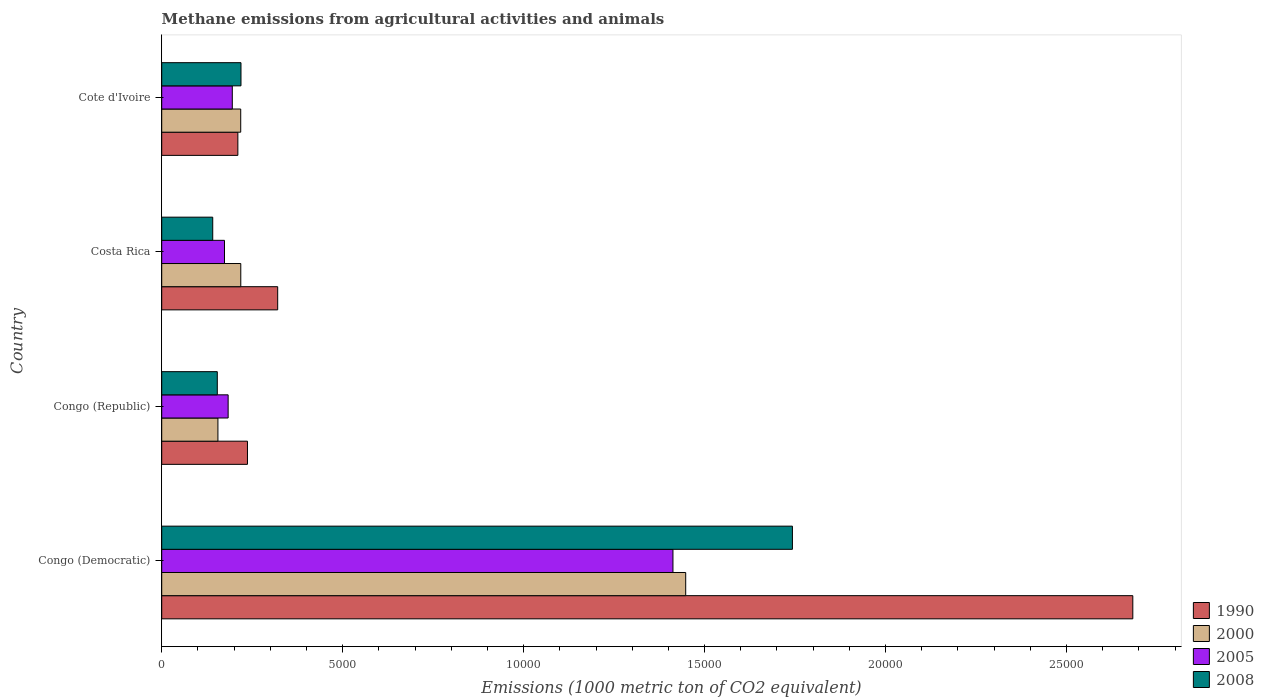Are the number of bars per tick equal to the number of legend labels?
Offer a terse response. Yes. Are the number of bars on each tick of the Y-axis equal?
Provide a succinct answer. Yes. How many bars are there on the 1st tick from the bottom?
Provide a short and direct response. 4. What is the label of the 1st group of bars from the top?
Your answer should be very brief. Cote d'Ivoire. In how many cases, is the number of bars for a given country not equal to the number of legend labels?
Offer a very short reply. 0. What is the amount of methane emitted in 2000 in Costa Rica?
Offer a very short reply. 2184.6. Across all countries, what is the maximum amount of methane emitted in 2005?
Make the answer very short. 1.41e+04. Across all countries, what is the minimum amount of methane emitted in 2005?
Ensure brevity in your answer.  1735. In which country was the amount of methane emitted in 2008 maximum?
Offer a very short reply. Congo (Democratic). In which country was the amount of methane emitted in 1990 minimum?
Your answer should be very brief. Cote d'Ivoire. What is the total amount of methane emitted in 2005 in the graph?
Ensure brevity in your answer.  1.96e+04. What is the difference between the amount of methane emitted in 2005 in Congo (Republic) and that in Costa Rica?
Offer a terse response. 100.4. What is the difference between the amount of methane emitted in 2008 in Congo (Democratic) and the amount of methane emitted in 1990 in Cote d'Ivoire?
Provide a succinct answer. 1.53e+04. What is the average amount of methane emitted in 2005 per country?
Give a very brief answer. 4911.57. What is the difference between the amount of methane emitted in 2005 and amount of methane emitted in 2008 in Cote d'Ivoire?
Your answer should be compact. -240.2. What is the ratio of the amount of methane emitted in 1990 in Congo (Republic) to that in Cote d'Ivoire?
Give a very brief answer. 1.13. Is the difference between the amount of methane emitted in 2005 in Congo (Democratic) and Cote d'Ivoire greater than the difference between the amount of methane emitted in 2008 in Congo (Democratic) and Cote d'Ivoire?
Keep it short and to the point. No. What is the difference between the highest and the second highest amount of methane emitted in 2005?
Offer a very short reply. 1.22e+04. What is the difference between the highest and the lowest amount of methane emitted in 1990?
Keep it short and to the point. 2.47e+04. In how many countries, is the amount of methane emitted in 2000 greater than the average amount of methane emitted in 2000 taken over all countries?
Your answer should be very brief. 1. Is it the case that in every country, the sum of the amount of methane emitted in 2008 and amount of methane emitted in 2000 is greater than the sum of amount of methane emitted in 2005 and amount of methane emitted in 1990?
Give a very brief answer. No. What does the 2nd bar from the top in Cote d'Ivoire represents?
Make the answer very short. 2005. Are all the bars in the graph horizontal?
Offer a terse response. Yes. How many countries are there in the graph?
Provide a succinct answer. 4. Does the graph contain any zero values?
Your response must be concise. No. How are the legend labels stacked?
Provide a succinct answer. Vertical. What is the title of the graph?
Make the answer very short. Methane emissions from agricultural activities and animals. What is the label or title of the X-axis?
Provide a succinct answer. Emissions (1000 metric ton of CO2 equivalent). What is the label or title of the Y-axis?
Provide a short and direct response. Country. What is the Emissions (1000 metric ton of CO2 equivalent) in 1990 in Congo (Democratic)?
Your response must be concise. 2.68e+04. What is the Emissions (1000 metric ton of CO2 equivalent) in 2000 in Congo (Democratic)?
Make the answer very short. 1.45e+04. What is the Emissions (1000 metric ton of CO2 equivalent) in 2005 in Congo (Democratic)?
Provide a short and direct response. 1.41e+04. What is the Emissions (1000 metric ton of CO2 equivalent) in 2008 in Congo (Democratic)?
Keep it short and to the point. 1.74e+04. What is the Emissions (1000 metric ton of CO2 equivalent) of 1990 in Congo (Republic)?
Make the answer very short. 2369.4. What is the Emissions (1000 metric ton of CO2 equivalent) of 2000 in Congo (Republic)?
Your answer should be compact. 1552.9. What is the Emissions (1000 metric ton of CO2 equivalent) in 2005 in Congo (Republic)?
Give a very brief answer. 1835.4. What is the Emissions (1000 metric ton of CO2 equivalent) in 2008 in Congo (Republic)?
Keep it short and to the point. 1535.9. What is the Emissions (1000 metric ton of CO2 equivalent) in 1990 in Costa Rica?
Provide a succinct answer. 3204.6. What is the Emissions (1000 metric ton of CO2 equivalent) of 2000 in Costa Rica?
Keep it short and to the point. 2184.6. What is the Emissions (1000 metric ton of CO2 equivalent) of 2005 in Costa Rica?
Provide a succinct answer. 1735. What is the Emissions (1000 metric ton of CO2 equivalent) in 2008 in Costa Rica?
Make the answer very short. 1409.6. What is the Emissions (1000 metric ton of CO2 equivalent) of 1990 in Cote d'Ivoire?
Your response must be concise. 2104. What is the Emissions (1000 metric ton of CO2 equivalent) in 2000 in Cote d'Ivoire?
Ensure brevity in your answer.  2183.1. What is the Emissions (1000 metric ton of CO2 equivalent) of 2005 in Cote d'Ivoire?
Provide a succinct answer. 1950.1. What is the Emissions (1000 metric ton of CO2 equivalent) of 2008 in Cote d'Ivoire?
Your response must be concise. 2190.3. Across all countries, what is the maximum Emissions (1000 metric ton of CO2 equivalent) of 1990?
Provide a short and direct response. 2.68e+04. Across all countries, what is the maximum Emissions (1000 metric ton of CO2 equivalent) of 2000?
Make the answer very short. 1.45e+04. Across all countries, what is the maximum Emissions (1000 metric ton of CO2 equivalent) in 2005?
Provide a short and direct response. 1.41e+04. Across all countries, what is the maximum Emissions (1000 metric ton of CO2 equivalent) in 2008?
Provide a short and direct response. 1.74e+04. Across all countries, what is the minimum Emissions (1000 metric ton of CO2 equivalent) of 1990?
Keep it short and to the point. 2104. Across all countries, what is the minimum Emissions (1000 metric ton of CO2 equivalent) of 2000?
Ensure brevity in your answer.  1552.9. Across all countries, what is the minimum Emissions (1000 metric ton of CO2 equivalent) of 2005?
Give a very brief answer. 1735. Across all countries, what is the minimum Emissions (1000 metric ton of CO2 equivalent) of 2008?
Provide a short and direct response. 1409.6. What is the total Emissions (1000 metric ton of CO2 equivalent) in 1990 in the graph?
Your response must be concise. 3.45e+04. What is the total Emissions (1000 metric ton of CO2 equivalent) in 2000 in the graph?
Your response must be concise. 2.04e+04. What is the total Emissions (1000 metric ton of CO2 equivalent) in 2005 in the graph?
Offer a very short reply. 1.96e+04. What is the total Emissions (1000 metric ton of CO2 equivalent) of 2008 in the graph?
Your answer should be very brief. 2.26e+04. What is the difference between the Emissions (1000 metric ton of CO2 equivalent) of 1990 in Congo (Democratic) and that in Congo (Republic)?
Give a very brief answer. 2.45e+04. What is the difference between the Emissions (1000 metric ton of CO2 equivalent) in 2000 in Congo (Democratic) and that in Congo (Republic)?
Ensure brevity in your answer.  1.29e+04. What is the difference between the Emissions (1000 metric ton of CO2 equivalent) of 2005 in Congo (Democratic) and that in Congo (Republic)?
Ensure brevity in your answer.  1.23e+04. What is the difference between the Emissions (1000 metric ton of CO2 equivalent) in 2008 in Congo (Democratic) and that in Congo (Republic)?
Offer a terse response. 1.59e+04. What is the difference between the Emissions (1000 metric ton of CO2 equivalent) of 1990 in Congo (Democratic) and that in Costa Rica?
Your answer should be very brief. 2.36e+04. What is the difference between the Emissions (1000 metric ton of CO2 equivalent) in 2000 in Congo (Democratic) and that in Costa Rica?
Offer a terse response. 1.23e+04. What is the difference between the Emissions (1000 metric ton of CO2 equivalent) of 2005 in Congo (Democratic) and that in Costa Rica?
Give a very brief answer. 1.24e+04. What is the difference between the Emissions (1000 metric ton of CO2 equivalent) in 2008 in Congo (Democratic) and that in Costa Rica?
Keep it short and to the point. 1.60e+04. What is the difference between the Emissions (1000 metric ton of CO2 equivalent) in 1990 in Congo (Democratic) and that in Cote d'Ivoire?
Provide a succinct answer. 2.47e+04. What is the difference between the Emissions (1000 metric ton of CO2 equivalent) in 2000 in Congo (Democratic) and that in Cote d'Ivoire?
Provide a succinct answer. 1.23e+04. What is the difference between the Emissions (1000 metric ton of CO2 equivalent) in 2005 in Congo (Democratic) and that in Cote d'Ivoire?
Your response must be concise. 1.22e+04. What is the difference between the Emissions (1000 metric ton of CO2 equivalent) of 2008 in Congo (Democratic) and that in Cote d'Ivoire?
Your answer should be compact. 1.52e+04. What is the difference between the Emissions (1000 metric ton of CO2 equivalent) in 1990 in Congo (Republic) and that in Costa Rica?
Your answer should be very brief. -835.2. What is the difference between the Emissions (1000 metric ton of CO2 equivalent) in 2000 in Congo (Republic) and that in Costa Rica?
Keep it short and to the point. -631.7. What is the difference between the Emissions (1000 metric ton of CO2 equivalent) of 2005 in Congo (Republic) and that in Costa Rica?
Make the answer very short. 100.4. What is the difference between the Emissions (1000 metric ton of CO2 equivalent) in 2008 in Congo (Republic) and that in Costa Rica?
Provide a short and direct response. 126.3. What is the difference between the Emissions (1000 metric ton of CO2 equivalent) in 1990 in Congo (Republic) and that in Cote d'Ivoire?
Make the answer very short. 265.4. What is the difference between the Emissions (1000 metric ton of CO2 equivalent) of 2000 in Congo (Republic) and that in Cote d'Ivoire?
Ensure brevity in your answer.  -630.2. What is the difference between the Emissions (1000 metric ton of CO2 equivalent) of 2005 in Congo (Republic) and that in Cote d'Ivoire?
Your response must be concise. -114.7. What is the difference between the Emissions (1000 metric ton of CO2 equivalent) in 2008 in Congo (Republic) and that in Cote d'Ivoire?
Your response must be concise. -654.4. What is the difference between the Emissions (1000 metric ton of CO2 equivalent) in 1990 in Costa Rica and that in Cote d'Ivoire?
Offer a terse response. 1100.6. What is the difference between the Emissions (1000 metric ton of CO2 equivalent) of 2000 in Costa Rica and that in Cote d'Ivoire?
Your answer should be compact. 1.5. What is the difference between the Emissions (1000 metric ton of CO2 equivalent) of 2005 in Costa Rica and that in Cote d'Ivoire?
Make the answer very short. -215.1. What is the difference between the Emissions (1000 metric ton of CO2 equivalent) in 2008 in Costa Rica and that in Cote d'Ivoire?
Make the answer very short. -780.7. What is the difference between the Emissions (1000 metric ton of CO2 equivalent) in 1990 in Congo (Democratic) and the Emissions (1000 metric ton of CO2 equivalent) in 2000 in Congo (Republic)?
Make the answer very short. 2.53e+04. What is the difference between the Emissions (1000 metric ton of CO2 equivalent) in 1990 in Congo (Democratic) and the Emissions (1000 metric ton of CO2 equivalent) in 2005 in Congo (Republic)?
Your answer should be very brief. 2.50e+04. What is the difference between the Emissions (1000 metric ton of CO2 equivalent) in 1990 in Congo (Democratic) and the Emissions (1000 metric ton of CO2 equivalent) in 2008 in Congo (Republic)?
Ensure brevity in your answer.  2.53e+04. What is the difference between the Emissions (1000 metric ton of CO2 equivalent) of 2000 in Congo (Democratic) and the Emissions (1000 metric ton of CO2 equivalent) of 2005 in Congo (Republic)?
Make the answer very short. 1.26e+04. What is the difference between the Emissions (1000 metric ton of CO2 equivalent) of 2000 in Congo (Democratic) and the Emissions (1000 metric ton of CO2 equivalent) of 2008 in Congo (Republic)?
Your response must be concise. 1.29e+04. What is the difference between the Emissions (1000 metric ton of CO2 equivalent) of 2005 in Congo (Democratic) and the Emissions (1000 metric ton of CO2 equivalent) of 2008 in Congo (Republic)?
Your response must be concise. 1.26e+04. What is the difference between the Emissions (1000 metric ton of CO2 equivalent) in 1990 in Congo (Democratic) and the Emissions (1000 metric ton of CO2 equivalent) in 2000 in Costa Rica?
Your response must be concise. 2.46e+04. What is the difference between the Emissions (1000 metric ton of CO2 equivalent) of 1990 in Congo (Democratic) and the Emissions (1000 metric ton of CO2 equivalent) of 2005 in Costa Rica?
Your answer should be compact. 2.51e+04. What is the difference between the Emissions (1000 metric ton of CO2 equivalent) in 1990 in Congo (Democratic) and the Emissions (1000 metric ton of CO2 equivalent) in 2008 in Costa Rica?
Your answer should be compact. 2.54e+04. What is the difference between the Emissions (1000 metric ton of CO2 equivalent) of 2000 in Congo (Democratic) and the Emissions (1000 metric ton of CO2 equivalent) of 2005 in Costa Rica?
Provide a succinct answer. 1.27e+04. What is the difference between the Emissions (1000 metric ton of CO2 equivalent) in 2000 in Congo (Democratic) and the Emissions (1000 metric ton of CO2 equivalent) in 2008 in Costa Rica?
Your answer should be very brief. 1.31e+04. What is the difference between the Emissions (1000 metric ton of CO2 equivalent) in 2005 in Congo (Democratic) and the Emissions (1000 metric ton of CO2 equivalent) in 2008 in Costa Rica?
Your response must be concise. 1.27e+04. What is the difference between the Emissions (1000 metric ton of CO2 equivalent) of 1990 in Congo (Democratic) and the Emissions (1000 metric ton of CO2 equivalent) of 2000 in Cote d'Ivoire?
Your answer should be very brief. 2.46e+04. What is the difference between the Emissions (1000 metric ton of CO2 equivalent) in 1990 in Congo (Democratic) and the Emissions (1000 metric ton of CO2 equivalent) in 2005 in Cote d'Ivoire?
Your answer should be compact. 2.49e+04. What is the difference between the Emissions (1000 metric ton of CO2 equivalent) of 1990 in Congo (Democratic) and the Emissions (1000 metric ton of CO2 equivalent) of 2008 in Cote d'Ivoire?
Provide a short and direct response. 2.46e+04. What is the difference between the Emissions (1000 metric ton of CO2 equivalent) in 2000 in Congo (Democratic) and the Emissions (1000 metric ton of CO2 equivalent) in 2005 in Cote d'Ivoire?
Offer a very short reply. 1.25e+04. What is the difference between the Emissions (1000 metric ton of CO2 equivalent) of 2000 in Congo (Democratic) and the Emissions (1000 metric ton of CO2 equivalent) of 2008 in Cote d'Ivoire?
Keep it short and to the point. 1.23e+04. What is the difference between the Emissions (1000 metric ton of CO2 equivalent) in 2005 in Congo (Democratic) and the Emissions (1000 metric ton of CO2 equivalent) in 2008 in Cote d'Ivoire?
Keep it short and to the point. 1.19e+04. What is the difference between the Emissions (1000 metric ton of CO2 equivalent) of 1990 in Congo (Republic) and the Emissions (1000 metric ton of CO2 equivalent) of 2000 in Costa Rica?
Your response must be concise. 184.8. What is the difference between the Emissions (1000 metric ton of CO2 equivalent) in 1990 in Congo (Republic) and the Emissions (1000 metric ton of CO2 equivalent) in 2005 in Costa Rica?
Provide a short and direct response. 634.4. What is the difference between the Emissions (1000 metric ton of CO2 equivalent) in 1990 in Congo (Republic) and the Emissions (1000 metric ton of CO2 equivalent) in 2008 in Costa Rica?
Provide a short and direct response. 959.8. What is the difference between the Emissions (1000 metric ton of CO2 equivalent) in 2000 in Congo (Republic) and the Emissions (1000 metric ton of CO2 equivalent) in 2005 in Costa Rica?
Your answer should be compact. -182.1. What is the difference between the Emissions (1000 metric ton of CO2 equivalent) of 2000 in Congo (Republic) and the Emissions (1000 metric ton of CO2 equivalent) of 2008 in Costa Rica?
Make the answer very short. 143.3. What is the difference between the Emissions (1000 metric ton of CO2 equivalent) of 2005 in Congo (Republic) and the Emissions (1000 metric ton of CO2 equivalent) of 2008 in Costa Rica?
Ensure brevity in your answer.  425.8. What is the difference between the Emissions (1000 metric ton of CO2 equivalent) in 1990 in Congo (Republic) and the Emissions (1000 metric ton of CO2 equivalent) in 2000 in Cote d'Ivoire?
Give a very brief answer. 186.3. What is the difference between the Emissions (1000 metric ton of CO2 equivalent) in 1990 in Congo (Republic) and the Emissions (1000 metric ton of CO2 equivalent) in 2005 in Cote d'Ivoire?
Your response must be concise. 419.3. What is the difference between the Emissions (1000 metric ton of CO2 equivalent) of 1990 in Congo (Republic) and the Emissions (1000 metric ton of CO2 equivalent) of 2008 in Cote d'Ivoire?
Make the answer very short. 179.1. What is the difference between the Emissions (1000 metric ton of CO2 equivalent) in 2000 in Congo (Republic) and the Emissions (1000 metric ton of CO2 equivalent) in 2005 in Cote d'Ivoire?
Give a very brief answer. -397.2. What is the difference between the Emissions (1000 metric ton of CO2 equivalent) in 2000 in Congo (Republic) and the Emissions (1000 metric ton of CO2 equivalent) in 2008 in Cote d'Ivoire?
Ensure brevity in your answer.  -637.4. What is the difference between the Emissions (1000 metric ton of CO2 equivalent) of 2005 in Congo (Republic) and the Emissions (1000 metric ton of CO2 equivalent) of 2008 in Cote d'Ivoire?
Make the answer very short. -354.9. What is the difference between the Emissions (1000 metric ton of CO2 equivalent) of 1990 in Costa Rica and the Emissions (1000 metric ton of CO2 equivalent) of 2000 in Cote d'Ivoire?
Make the answer very short. 1021.5. What is the difference between the Emissions (1000 metric ton of CO2 equivalent) of 1990 in Costa Rica and the Emissions (1000 metric ton of CO2 equivalent) of 2005 in Cote d'Ivoire?
Keep it short and to the point. 1254.5. What is the difference between the Emissions (1000 metric ton of CO2 equivalent) of 1990 in Costa Rica and the Emissions (1000 metric ton of CO2 equivalent) of 2008 in Cote d'Ivoire?
Provide a succinct answer. 1014.3. What is the difference between the Emissions (1000 metric ton of CO2 equivalent) of 2000 in Costa Rica and the Emissions (1000 metric ton of CO2 equivalent) of 2005 in Cote d'Ivoire?
Your answer should be compact. 234.5. What is the difference between the Emissions (1000 metric ton of CO2 equivalent) of 2000 in Costa Rica and the Emissions (1000 metric ton of CO2 equivalent) of 2008 in Cote d'Ivoire?
Give a very brief answer. -5.7. What is the difference between the Emissions (1000 metric ton of CO2 equivalent) in 2005 in Costa Rica and the Emissions (1000 metric ton of CO2 equivalent) in 2008 in Cote d'Ivoire?
Keep it short and to the point. -455.3. What is the average Emissions (1000 metric ton of CO2 equivalent) in 1990 per country?
Your answer should be very brief. 8627.42. What is the average Emissions (1000 metric ton of CO2 equivalent) in 2000 per country?
Provide a succinct answer. 5099.6. What is the average Emissions (1000 metric ton of CO2 equivalent) in 2005 per country?
Give a very brief answer. 4911.57. What is the average Emissions (1000 metric ton of CO2 equivalent) of 2008 per country?
Give a very brief answer. 5640.65. What is the difference between the Emissions (1000 metric ton of CO2 equivalent) in 1990 and Emissions (1000 metric ton of CO2 equivalent) in 2000 in Congo (Democratic)?
Provide a short and direct response. 1.24e+04. What is the difference between the Emissions (1000 metric ton of CO2 equivalent) in 1990 and Emissions (1000 metric ton of CO2 equivalent) in 2005 in Congo (Democratic)?
Your answer should be compact. 1.27e+04. What is the difference between the Emissions (1000 metric ton of CO2 equivalent) in 1990 and Emissions (1000 metric ton of CO2 equivalent) in 2008 in Congo (Democratic)?
Your answer should be very brief. 9404.9. What is the difference between the Emissions (1000 metric ton of CO2 equivalent) in 2000 and Emissions (1000 metric ton of CO2 equivalent) in 2005 in Congo (Democratic)?
Your answer should be very brief. 352. What is the difference between the Emissions (1000 metric ton of CO2 equivalent) of 2000 and Emissions (1000 metric ton of CO2 equivalent) of 2008 in Congo (Democratic)?
Offer a very short reply. -2949. What is the difference between the Emissions (1000 metric ton of CO2 equivalent) of 2005 and Emissions (1000 metric ton of CO2 equivalent) of 2008 in Congo (Democratic)?
Provide a succinct answer. -3301. What is the difference between the Emissions (1000 metric ton of CO2 equivalent) in 1990 and Emissions (1000 metric ton of CO2 equivalent) in 2000 in Congo (Republic)?
Your answer should be very brief. 816.5. What is the difference between the Emissions (1000 metric ton of CO2 equivalent) of 1990 and Emissions (1000 metric ton of CO2 equivalent) of 2005 in Congo (Republic)?
Offer a terse response. 534. What is the difference between the Emissions (1000 metric ton of CO2 equivalent) in 1990 and Emissions (1000 metric ton of CO2 equivalent) in 2008 in Congo (Republic)?
Give a very brief answer. 833.5. What is the difference between the Emissions (1000 metric ton of CO2 equivalent) in 2000 and Emissions (1000 metric ton of CO2 equivalent) in 2005 in Congo (Republic)?
Offer a terse response. -282.5. What is the difference between the Emissions (1000 metric ton of CO2 equivalent) in 2000 and Emissions (1000 metric ton of CO2 equivalent) in 2008 in Congo (Republic)?
Ensure brevity in your answer.  17. What is the difference between the Emissions (1000 metric ton of CO2 equivalent) of 2005 and Emissions (1000 metric ton of CO2 equivalent) of 2008 in Congo (Republic)?
Ensure brevity in your answer.  299.5. What is the difference between the Emissions (1000 metric ton of CO2 equivalent) in 1990 and Emissions (1000 metric ton of CO2 equivalent) in 2000 in Costa Rica?
Ensure brevity in your answer.  1020. What is the difference between the Emissions (1000 metric ton of CO2 equivalent) of 1990 and Emissions (1000 metric ton of CO2 equivalent) of 2005 in Costa Rica?
Offer a terse response. 1469.6. What is the difference between the Emissions (1000 metric ton of CO2 equivalent) of 1990 and Emissions (1000 metric ton of CO2 equivalent) of 2008 in Costa Rica?
Your response must be concise. 1795. What is the difference between the Emissions (1000 metric ton of CO2 equivalent) of 2000 and Emissions (1000 metric ton of CO2 equivalent) of 2005 in Costa Rica?
Offer a terse response. 449.6. What is the difference between the Emissions (1000 metric ton of CO2 equivalent) in 2000 and Emissions (1000 metric ton of CO2 equivalent) in 2008 in Costa Rica?
Offer a very short reply. 775. What is the difference between the Emissions (1000 metric ton of CO2 equivalent) in 2005 and Emissions (1000 metric ton of CO2 equivalent) in 2008 in Costa Rica?
Your answer should be compact. 325.4. What is the difference between the Emissions (1000 metric ton of CO2 equivalent) of 1990 and Emissions (1000 metric ton of CO2 equivalent) of 2000 in Cote d'Ivoire?
Your response must be concise. -79.1. What is the difference between the Emissions (1000 metric ton of CO2 equivalent) in 1990 and Emissions (1000 metric ton of CO2 equivalent) in 2005 in Cote d'Ivoire?
Provide a short and direct response. 153.9. What is the difference between the Emissions (1000 metric ton of CO2 equivalent) of 1990 and Emissions (1000 metric ton of CO2 equivalent) of 2008 in Cote d'Ivoire?
Your answer should be compact. -86.3. What is the difference between the Emissions (1000 metric ton of CO2 equivalent) of 2000 and Emissions (1000 metric ton of CO2 equivalent) of 2005 in Cote d'Ivoire?
Your answer should be compact. 233. What is the difference between the Emissions (1000 metric ton of CO2 equivalent) in 2005 and Emissions (1000 metric ton of CO2 equivalent) in 2008 in Cote d'Ivoire?
Provide a succinct answer. -240.2. What is the ratio of the Emissions (1000 metric ton of CO2 equivalent) in 1990 in Congo (Democratic) to that in Congo (Republic)?
Make the answer very short. 11.32. What is the ratio of the Emissions (1000 metric ton of CO2 equivalent) of 2000 in Congo (Democratic) to that in Congo (Republic)?
Keep it short and to the point. 9.32. What is the ratio of the Emissions (1000 metric ton of CO2 equivalent) of 2005 in Congo (Democratic) to that in Congo (Republic)?
Offer a very short reply. 7.7. What is the ratio of the Emissions (1000 metric ton of CO2 equivalent) in 2008 in Congo (Democratic) to that in Congo (Republic)?
Your answer should be very brief. 11.35. What is the ratio of the Emissions (1000 metric ton of CO2 equivalent) in 1990 in Congo (Democratic) to that in Costa Rica?
Offer a terse response. 8.37. What is the ratio of the Emissions (1000 metric ton of CO2 equivalent) in 2000 in Congo (Democratic) to that in Costa Rica?
Ensure brevity in your answer.  6.63. What is the ratio of the Emissions (1000 metric ton of CO2 equivalent) in 2005 in Congo (Democratic) to that in Costa Rica?
Keep it short and to the point. 8.14. What is the ratio of the Emissions (1000 metric ton of CO2 equivalent) of 2008 in Congo (Democratic) to that in Costa Rica?
Give a very brief answer. 12.36. What is the ratio of the Emissions (1000 metric ton of CO2 equivalent) in 1990 in Congo (Democratic) to that in Cote d'Ivoire?
Offer a terse response. 12.75. What is the ratio of the Emissions (1000 metric ton of CO2 equivalent) in 2000 in Congo (Democratic) to that in Cote d'Ivoire?
Make the answer very short. 6.63. What is the ratio of the Emissions (1000 metric ton of CO2 equivalent) in 2005 in Congo (Democratic) to that in Cote d'Ivoire?
Your answer should be compact. 7.24. What is the ratio of the Emissions (1000 metric ton of CO2 equivalent) of 2008 in Congo (Democratic) to that in Cote d'Ivoire?
Your response must be concise. 7.96. What is the ratio of the Emissions (1000 metric ton of CO2 equivalent) in 1990 in Congo (Republic) to that in Costa Rica?
Offer a terse response. 0.74. What is the ratio of the Emissions (1000 metric ton of CO2 equivalent) of 2000 in Congo (Republic) to that in Costa Rica?
Give a very brief answer. 0.71. What is the ratio of the Emissions (1000 metric ton of CO2 equivalent) of 2005 in Congo (Republic) to that in Costa Rica?
Your response must be concise. 1.06. What is the ratio of the Emissions (1000 metric ton of CO2 equivalent) of 2008 in Congo (Republic) to that in Costa Rica?
Give a very brief answer. 1.09. What is the ratio of the Emissions (1000 metric ton of CO2 equivalent) of 1990 in Congo (Republic) to that in Cote d'Ivoire?
Your answer should be very brief. 1.13. What is the ratio of the Emissions (1000 metric ton of CO2 equivalent) of 2000 in Congo (Republic) to that in Cote d'Ivoire?
Keep it short and to the point. 0.71. What is the ratio of the Emissions (1000 metric ton of CO2 equivalent) in 2005 in Congo (Republic) to that in Cote d'Ivoire?
Keep it short and to the point. 0.94. What is the ratio of the Emissions (1000 metric ton of CO2 equivalent) in 2008 in Congo (Republic) to that in Cote d'Ivoire?
Your answer should be compact. 0.7. What is the ratio of the Emissions (1000 metric ton of CO2 equivalent) in 1990 in Costa Rica to that in Cote d'Ivoire?
Offer a terse response. 1.52. What is the ratio of the Emissions (1000 metric ton of CO2 equivalent) of 2005 in Costa Rica to that in Cote d'Ivoire?
Provide a short and direct response. 0.89. What is the ratio of the Emissions (1000 metric ton of CO2 equivalent) of 2008 in Costa Rica to that in Cote d'Ivoire?
Your response must be concise. 0.64. What is the difference between the highest and the second highest Emissions (1000 metric ton of CO2 equivalent) in 1990?
Ensure brevity in your answer.  2.36e+04. What is the difference between the highest and the second highest Emissions (1000 metric ton of CO2 equivalent) of 2000?
Provide a succinct answer. 1.23e+04. What is the difference between the highest and the second highest Emissions (1000 metric ton of CO2 equivalent) of 2005?
Make the answer very short. 1.22e+04. What is the difference between the highest and the second highest Emissions (1000 metric ton of CO2 equivalent) of 2008?
Your answer should be compact. 1.52e+04. What is the difference between the highest and the lowest Emissions (1000 metric ton of CO2 equivalent) of 1990?
Provide a succinct answer. 2.47e+04. What is the difference between the highest and the lowest Emissions (1000 metric ton of CO2 equivalent) in 2000?
Provide a short and direct response. 1.29e+04. What is the difference between the highest and the lowest Emissions (1000 metric ton of CO2 equivalent) in 2005?
Your answer should be very brief. 1.24e+04. What is the difference between the highest and the lowest Emissions (1000 metric ton of CO2 equivalent) in 2008?
Ensure brevity in your answer.  1.60e+04. 